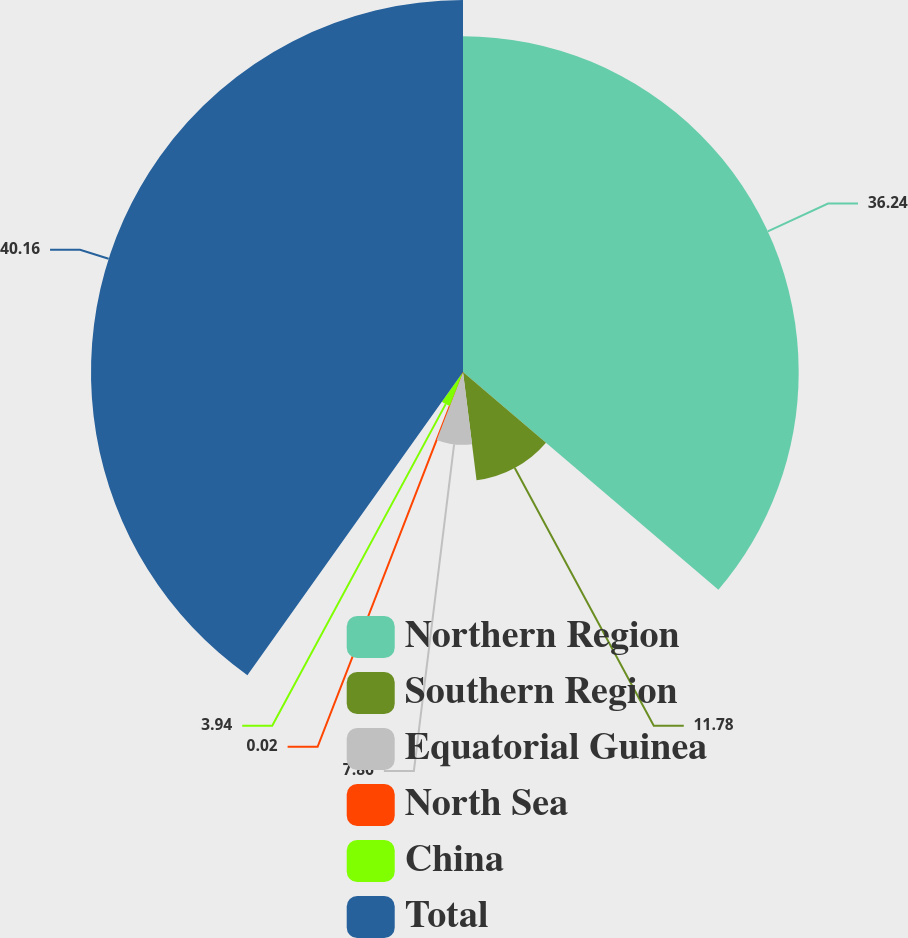Convert chart. <chart><loc_0><loc_0><loc_500><loc_500><pie_chart><fcel>Northern Region<fcel>Southern Region<fcel>Equatorial Guinea<fcel>North Sea<fcel>China<fcel>Total<nl><fcel>36.24%<fcel>11.78%<fcel>7.86%<fcel>0.02%<fcel>3.94%<fcel>40.16%<nl></chart> 